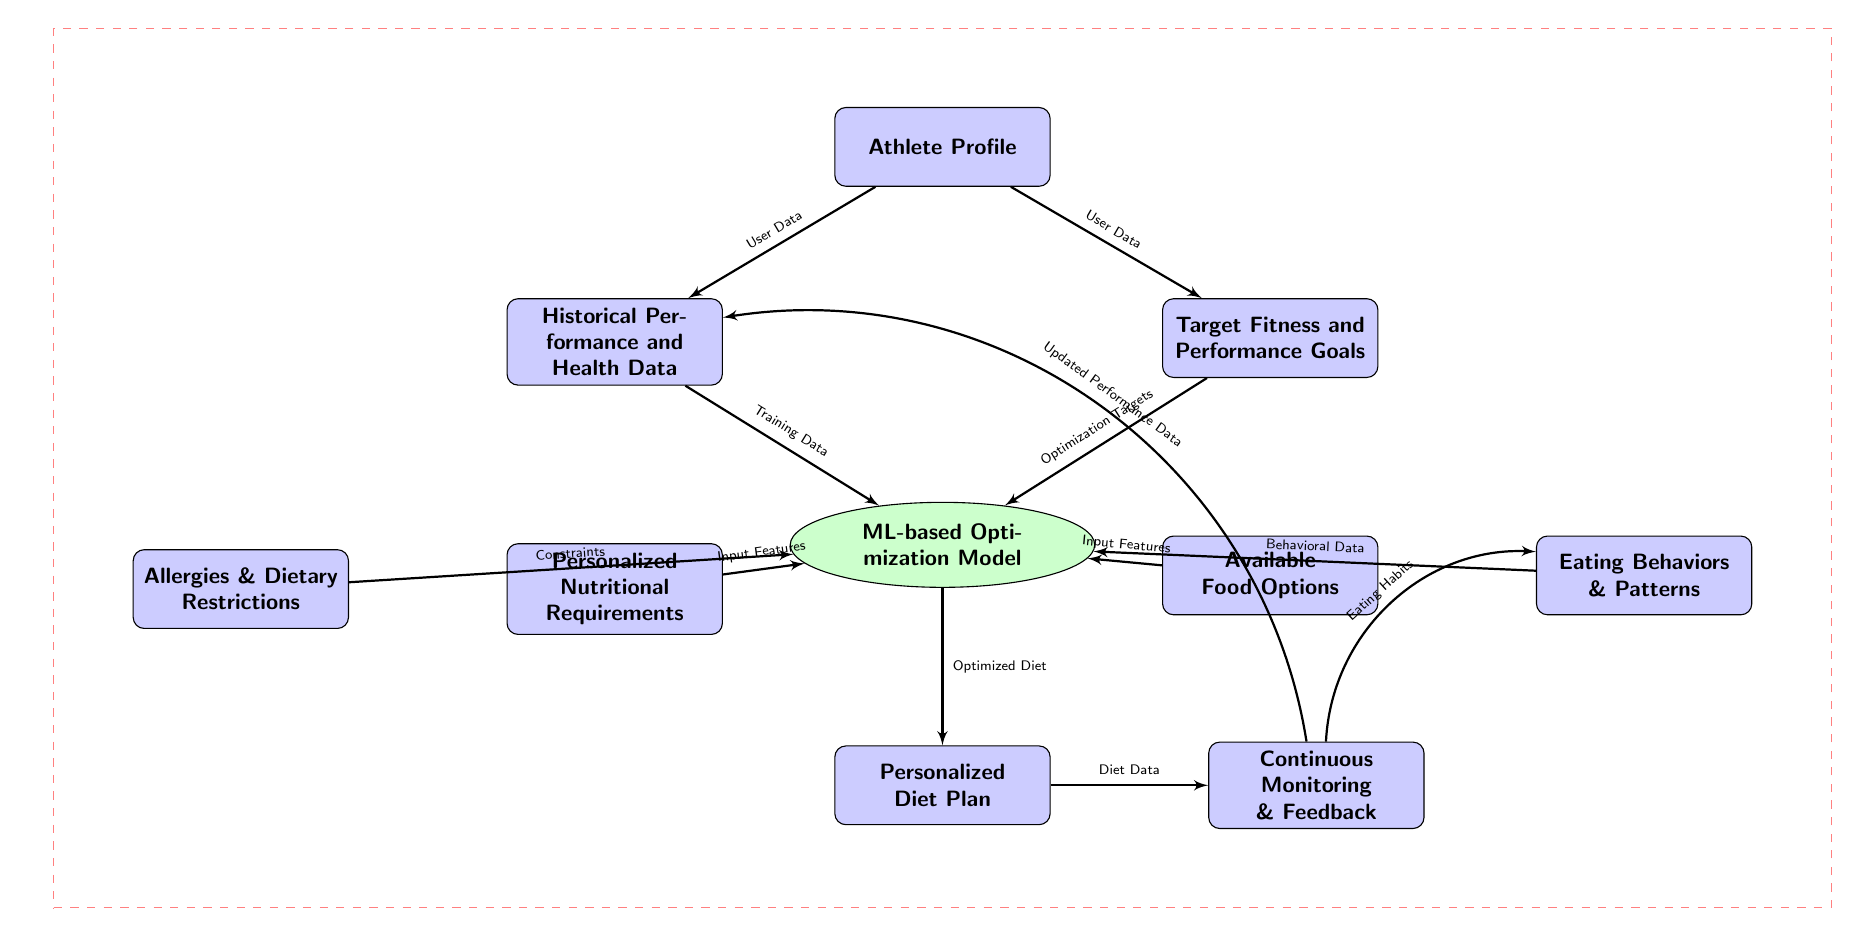What is the first block in the diagram? The first block in the diagram is labeled "Athlete Profile," which is situated at the top and serves as the starting point for the input data.
Answer: Athlete Profile How many blocks are there in the diagram? The diagram contains a total of 9 blocks. These include Athlete Profile, Historical Performance and Health Data, Target Fitness and Performance Goals, Personalized Nutritional Requirements, Available Food Options, Allergies & Dietary Restrictions, Eating Behaviors & Patterns, Personalized Diet Plan, and Continuous Monitoring & Feedback.
Answer: 9 What type of data does the block "Historical Performance and Health Data" provide? The block "Historical Performance and Health Data" provides "Training Data," which contributes to the machine learning model's optimization processes.
Answer: Training Data Which block directly leads to the "Personalized Diet Plan"? The "ML-based Optimization Model" is the block that directly leads to the "Personalized Diet Plan," suggesting it processes inputs and produces the dietary recommendations.
Answer: ML-based Optimization Model What relationship does the "Feedback" block have with "Historical Performance and Health Data"? The "Feedback" block has an outgoing relationship to the "Historical Performance and Health Data," indicated by the updating process. This suggests that feedback loops back to the performance and health data to improve the model's accuracy over time.
Answer: Updated Performance Data How does the "Personalized Nutritional Requirements" connect to the ML model? The "Personalized Nutritional Requirements" connects to the ML model as "Input Features," which means its data is utilized in the optimization process to generate the diet plan.
Answer: Input Features What type of data is required as a "Constraint" by the ML model? The data required as a "Constraint" by the ML model comes from the block labeled "Allergies & Dietary Restrictions." This data affects the optimization process by imposing limits on options.
Answer: Allergies & Dietary Restrictions What is the ultimate goal of the flow from "Athlete Profile" to "Personalized Diet Plan"? The ultimate goal of the flow from "Athlete Profile" to "Personalized Diet Plan" is to generate an optimized diet tailored to the specific needs and goals of the athlete based on their profile and data inputs.
Answer: Optimized Diet Which block is linked to both "Eating Behaviors & Patterns" and "Continuous Monitoring & Feedback"? The block "Feedback" is linked to both "Eating Behaviors & Patterns" and "Continuous Monitoring," implying that eating habits need consistent evaluation and adjustment based on the dietary plan's effectiveness over time.
Answer: Feedback 